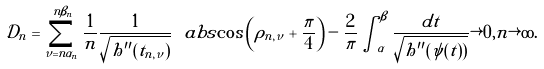<formula> <loc_0><loc_0><loc_500><loc_500>\mathcal { D } _ { n } = \sum _ { \nu = n \alpha _ { n } } ^ { n \beta _ { n } } \frac { 1 } { n } \frac { 1 } { \sqrt { h ^ { \prime \prime } ( t _ { n , \nu } ) } } \ a b s { \cos \left ( \rho _ { n , \nu } + \frac { \pi } { 4 } \right ) } - \frac { 2 } { \pi } \int _ { \alpha } ^ { \beta } \frac { d t } { \sqrt { h ^ { \prime \prime } ( \psi ( t ) ) } } \rightarrow 0 , n \rightarrow \infty .</formula> 